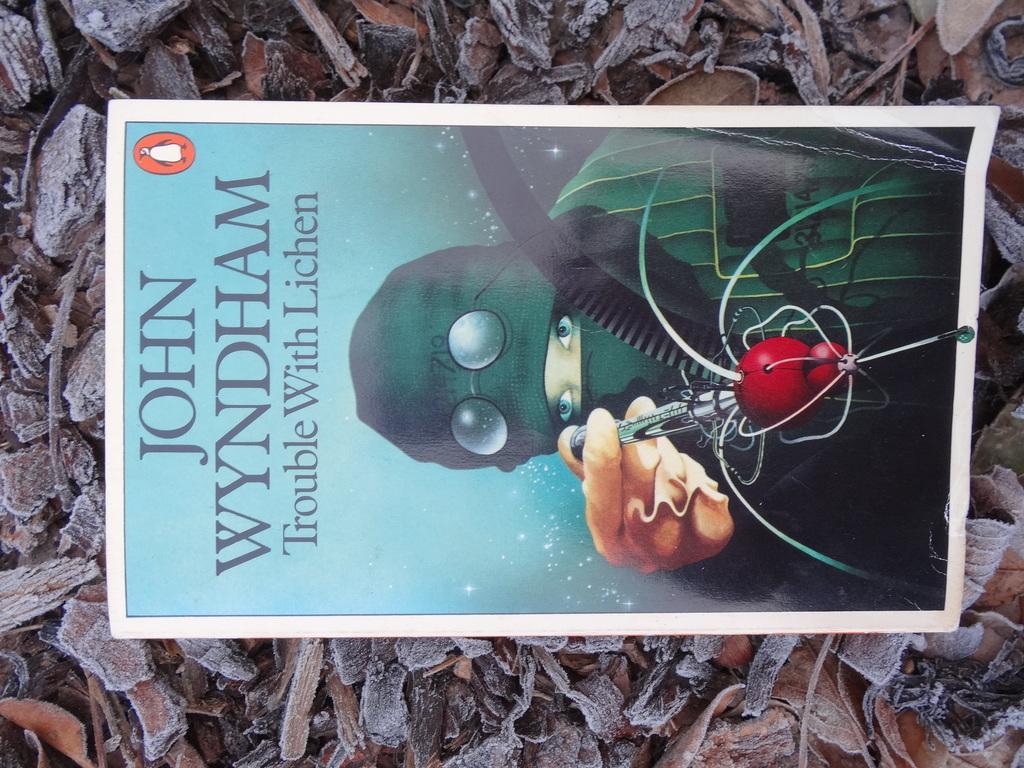Can you describe this image briefly? This picture is to be clicked outside. In the foreground we can see there are some objects lying on the floor. In the center there is a paper on which the text is printed and a picture of a person holding some objects is printed. 